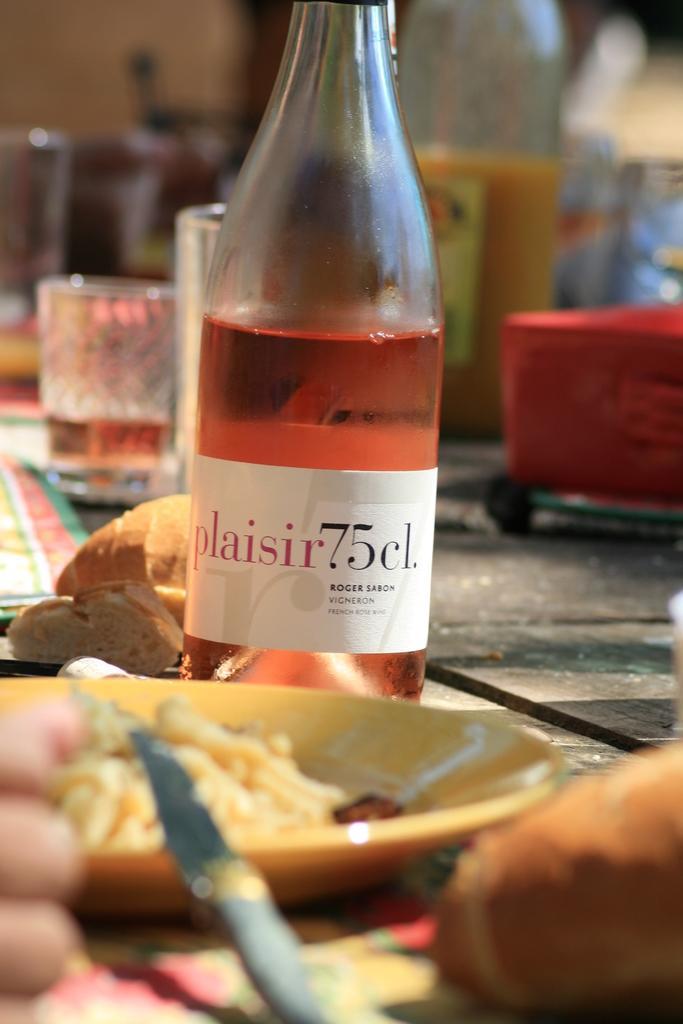Describe this image in one or two sentences. In the image we can see there is a table on which there is a juice bottle and in plate there are salad, there is knife, glass of juice and a box. 